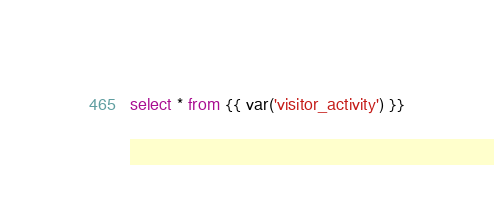<code> <loc_0><loc_0><loc_500><loc_500><_SQL_>select * from {{ var('visitor_activity') }}
</code> 